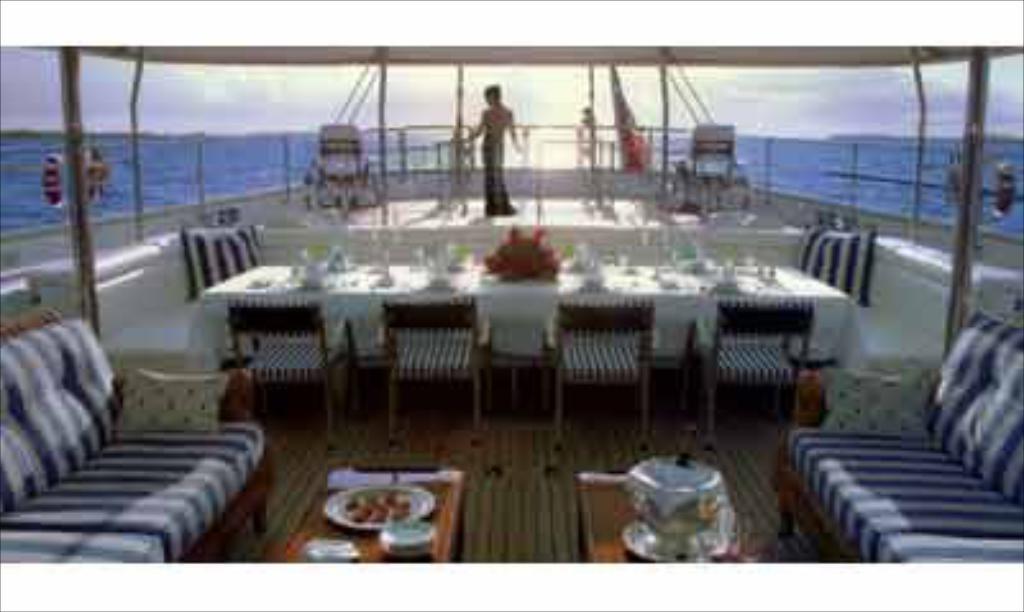Describe this image in one or two sentences. In this image I can see a person standing. I can also see few glasses on the table. In front I can see two couches, background I can see water in blue color and sky in white color. 